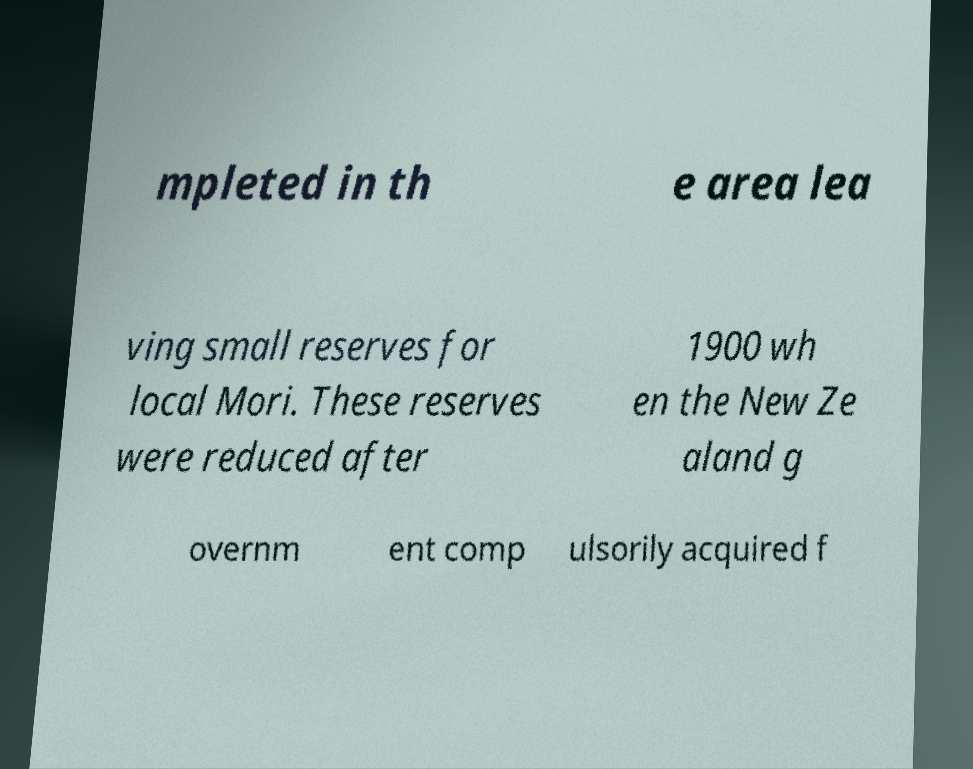Can you accurately transcribe the text from the provided image for me? mpleted in th e area lea ving small reserves for local Mori. These reserves were reduced after 1900 wh en the New Ze aland g overnm ent comp ulsorily acquired f 